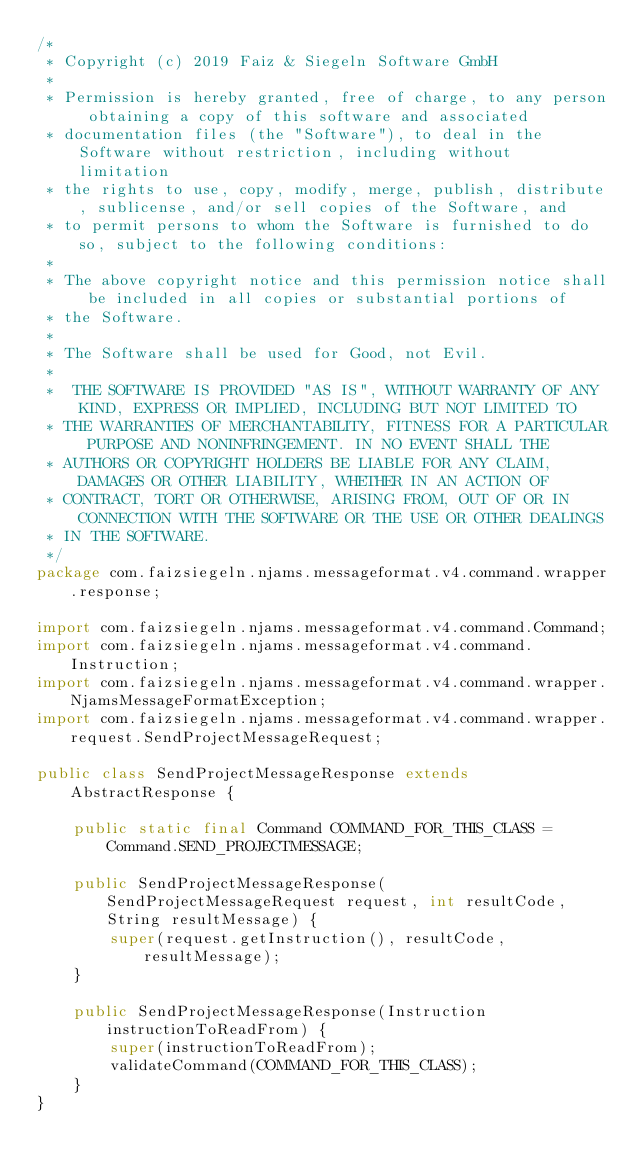<code> <loc_0><loc_0><loc_500><loc_500><_Java_>/*
 * Copyright (c) 2019 Faiz & Siegeln Software GmbH
 *
 * Permission is hereby granted, free of charge, to any person obtaining a copy of this software and associated
 * documentation files (the "Software"), to deal in the Software without restriction, including without limitation
 * the rights to use, copy, modify, merge, publish, distribute, sublicense, and/or sell copies of the Software, and
 * to permit persons to whom the Software is furnished to do so, subject to the following conditions:
 *
 * The above copyright notice and this permission notice shall be included in all copies or substantial portions of
 * the Software.
 *
 * The Software shall be used for Good, not Evil.
 *
 *  THE SOFTWARE IS PROVIDED "AS IS", WITHOUT WARRANTY OF ANY KIND, EXPRESS OR IMPLIED, INCLUDING BUT NOT LIMITED TO
 * THE WARRANTIES OF MERCHANTABILITY, FITNESS FOR A PARTICULAR PURPOSE AND NONINFRINGEMENT. IN NO EVENT SHALL THE
 * AUTHORS OR COPYRIGHT HOLDERS BE LIABLE FOR ANY CLAIM, DAMAGES OR OTHER LIABILITY, WHETHER IN AN ACTION OF
 * CONTRACT, TORT OR OTHERWISE, ARISING FROM, OUT OF OR IN CONNECTION WITH THE SOFTWARE OR THE USE OR OTHER DEALINGS
 * IN THE SOFTWARE.
 */
package com.faizsiegeln.njams.messageformat.v4.command.wrapper.response;

import com.faizsiegeln.njams.messageformat.v4.command.Command;
import com.faizsiegeln.njams.messageformat.v4.command.Instruction;
import com.faizsiegeln.njams.messageformat.v4.command.wrapper.NjamsMessageFormatException;
import com.faizsiegeln.njams.messageformat.v4.command.wrapper.request.SendProjectMessageRequest;

public class SendProjectMessageResponse extends AbstractResponse {

    public static final Command COMMAND_FOR_THIS_CLASS = Command.SEND_PROJECTMESSAGE;

    public SendProjectMessageResponse(SendProjectMessageRequest request, int resultCode, String resultMessage) {
        super(request.getInstruction(), resultCode, resultMessage);
    }

    public SendProjectMessageResponse(Instruction instructionToReadFrom) {
        super(instructionToReadFrom);
        validateCommand(COMMAND_FOR_THIS_CLASS);
    }
}
</code> 